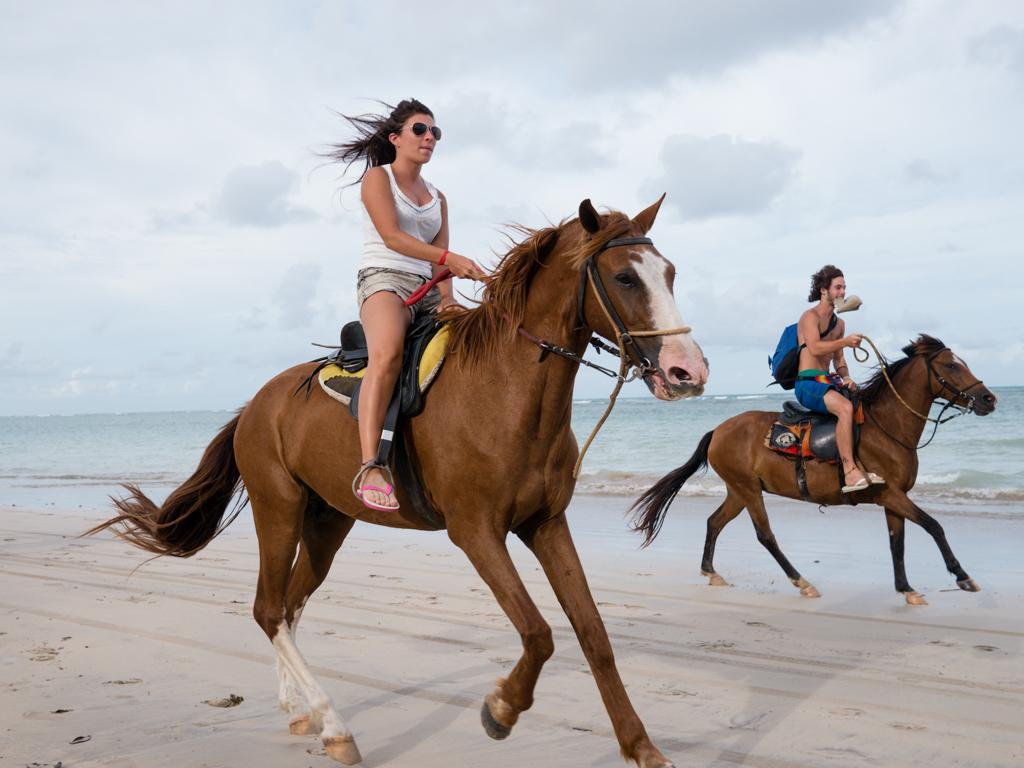Describe this image in one or two sentences. In this picture we can see a woman and a man riding the horse, at the beach side and the sky is full of clouds. 